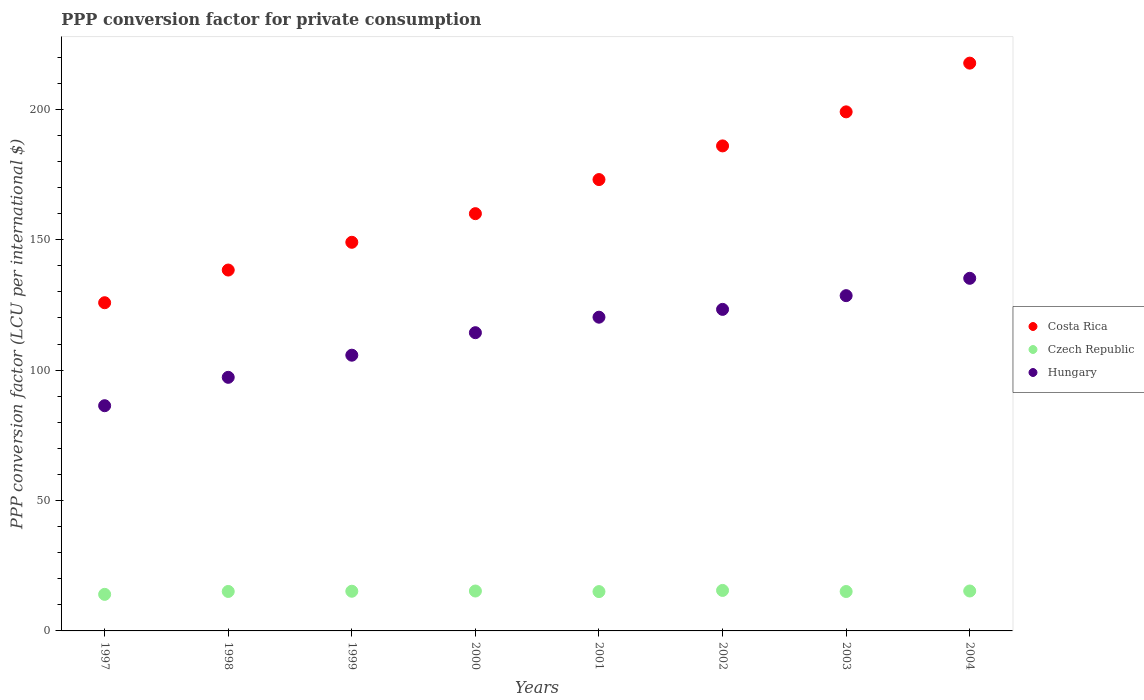How many different coloured dotlines are there?
Give a very brief answer. 3. Is the number of dotlines equal to the number of legend labels?
Make the answer very short. Yes. What is the PPP conversion factor for private consumption in Hungary in 2004?
Make the answer very short. 135.21. Across all years, what is the maximum PPP conversion factor for private consumption in Hungary?
Your answer should be compact. 135.21. Across all years, what is the minimum PPP conversion factor for private consumption in Costa Rica?
Your answer should be very brief. 125.85. In which year was the PPP conversion factor for private consumption in Hungary maximum?
Ensure brevity in your answer.  2004. In which year was the PPP conversion factor for private consumption in Hungary minimum?
Ensure brevity in your answer.  1997. What is the total PPP conversion factor for private consumption in Hungary in the graph?
Your answer should be compact. 911.07. What is the difference between the PPP conversion factor for private consumption in Czech Republic in 1999 and that in 2002?
Keep it short and to the point. -0.31. What is the difference between the PPP conversion factor for private consumption in Costa Rica in 2003 and the PPP conversion factor for private consumption in Czech Republic in 2001?
Your answer should be very brief. 183.96. What is the average PPP conversion factor for private consumption in Czech Republic per year?
Provide a short and direct response. 15.09. In the year 2003, what is the difference between the PPP conversion factor for private consumption in Czech Republic and PPP conversion factor for private consumption in Costa Rica?
Keep it short and to the point. -183.93. What is the ratio of the PPP conversion factor for private consumption in Hungary in 2000 to that in 2003?
Keep it short and to the point. 0.89. Is the difference between the PPP conversion factor for private consumption in Czech Republic in 1999 and 2003 greater than the difference between the PPP conversion factor for private consumption in Costa Rica in 1999 and 2003?
Keep it short and to the point. Yes. What is the difference between the highest and the second highest PPP conversion factor for private consumption in Hungary?
Your answer should be very brief. 6.65. What is the difference between the highest and the lowest PPP conversion factor for private consumption in Czech Republic?
Provide a short and direct response. 1.51. In how many years, is the PPP conversion factor for private consumption in Hungary greater than the average PPP conversion factor for private consumption in Hungary taken over all years?
Give a very brief answer. 5. Is the sum of the PPP conversion factor for private consumption in Costa Rica in 2000 and 2003 greater than the maximum PPP conversion factor for private consumption in Czech Republic across all years?
Your response must be concise. Yes. Is the PPP conversion factor for private consumption in Czech Republic strictly less than the PPP conversion factor for private consumption in Costa Rica over the years?
Make the answer very short. Yes. How many dotlines are there?
Offer a terse response. 3. Are the values on the major ticks of Y-axis written in scientific E-notation?
Give a very brief answer. No. Does the graph contain any zero values?
Your answer should be compact. No. How many legend labels are there?
Make the answer very short. 3. How are the legend labels stacked?
Provide a succinct answer. Vertical. What is the title of the graph?
Offer a terse response. PPP conversion factor for private consumption. Does "India" appear as one of the legend labels in the graph?
Ensure brevity in your answer.  No. What is the label or title of the X-axis?
Your answer should be compact. Years. What is the label or title of the Y-axis?
Make the answer very short. PPP conversion factor (LCU per international $). What is the PPP conversion factor (LCU per international $) of Costa Rica in 1997?
Offer a very short reply. 125.85. What is the PPP conversion factor (LCU per international $) in Czech Republic in 1997?
Give a very brief answer. 14.02. What is the PPP conversion factor (LCU per international $) in Hungary in 1997?
Make the answer very short. 86.36. What is the PPP conversion factor (LCU per international $) in Costa Rica in 1998?
Ensure brevity in your answer.  138.38. What is the PPP conversion factor (LCU per international $) in Czech Republic in 1998?
Give a very brief answer. 15.13. What is the PPP conversion factor (LCU per international $) of Hungary in 1998?
Offer a very short reply. 97.24. What is the PPP conversion factor (LCU per international $) in Costa Rica in 1999?
Keep it short and to the point. 149.02. What is the PPP conversion factor (LCU per international $) in Czech Republic in 1999?
Provide a succinct answer. 15.21. What is the PPP conversion factor (LCU per international $) of Hungary in 1999?
Offer a terse response. 105.73. What is the PPP conversion factor (LCU per international $) of Costa Rica in 2000?
Give a very brief answer. 160. What is the PPP conversion factor (LCU per international $) of Czech Republic in 2000?
Your answer should be very brief. 15.3. What is the PPP conversion factor (LCU per international $) in Hungary in 2000?
Give a very brief answer. 114.36. What is the PPP conversion factor (LCU per international $) in Costa Rica in 2001?
Your answer should be compact. 173.07. What is the PPP conversion factor (LCU per international $) of Czech Republic in 2001?
Provide a short and direct response. 15.08. What is the PPP conversion factor (LCU per international $) of Hungary in 2001?
Provide a succinct answer. 120.3. What is the PPP conversion factor (LCU per international $) in Costa Rica in 2002?
Make the answer very short. 185.99. What is the PPP conversion factor (LCU per international $) of Czech Republic in 2002?
Provide a succinct answer. 15.53. What is the PPP conversion factor (LCU per international $) of Hungary in 2002?
Provide a short and direct response. 123.3. What is the PPP conversion factor (LCU per international $) of Costa Rica in 2003?
Your answer should be very brief. 199.04. What is the PPP conversion factor (LCU per international $) in Czech Republic in 2003?
Offer a very short reply. 15.11. What is the PPP conversion factor (LCU per international $) of Hungary in 2003?
Offer a very short reply. 128.56. What is the PPP conversion factor (LCU per international $) in Costa Rica in 2004?
Give a very brief answer. 217.72. What is the PPP conversion factor (LCU per international $) of Czech Republic in 2004?
Provide a succinct answer. 15.31. What is the PPP conversion factor (LCU per international $) in Hungary in 2004?
Ensure brevity in your answer.  135.21. Across all years, what is the maximum PPP conversion factor (LCU per international $) in Costa Rica?
Give a very brief answer. 217.72. Across all years, what is the maximum PPP conversion factor (LCU per international $) of Czech Republic?
Offer a terse response. 15.53. Across all years, what is the maximum PPP conversion factor (LCU per international $) of Hungary?
Make the answer very short. 135.21. Across all years, what is the minimum PPP conversion factor (LCU per international $) of Costa Rica?
Give a very brief answer. 125.85. Across all years, what is the minimum PPP conversion factor (LCU per international $) in Czech Republic?
Your response must be concise. 14.02. Across all years, what is the minimum PPP conversion factor (LCU per international $) in Hungary?
Provide a short and direct response. 86.36. What is the total PPP conversion factor (LCU per international $) of Costa Rica in the graph?
Your answer should be very brief. 1349.08. What is the total PPP conversion factor (LCU per international $) in Czech Republic in the graph?
Provide a short and direct response. 120.7. What is the total PPP conversion factor (LCU per international $) of Hungary in the graph?
Your answer should be very brief. 911.07. What is the difference between the PPP conversion factor (LCU per international $) of Costa Rica in 1997 and that in 1998?
Ensure brevity in your answer.  -12.53. What is the difference between the PPP conversion factor (LCU per international $) in Czech Republic in 1997 and that in 1998?
Make the answer very short. -1.11. What is the difference between the PPP conversion factor (LCU per international $) in Hungary in 1997 and that in 1998?
Provide a short and direct response. -10.88. What is the difference between the PPP conversion factor (LCU per international $) of Costa Rica in 1997 and that in 1999?
Give a very brief answer. -23.17. What is the difference between the PPP conversion factor (LCU per international $) in Czech Republic in 1997 and that in 1999?
Give a very brief answer. -1.2. What is the difference between the PPP conversion factor (LCU per international $) of Hungary in 1997 and that in 1999?
Offer a very short reply. -19.37. What is the difference between the PPP conversion factor (LCU per international $) in Costa Rica in 1997 and that in 2000?
Ensure brevity in your answer.  -34.15. What is the difference between the PPP conversion factor (LCU per international $) of Czech Republic in 1997 and that in 2000?
Provide a short and direct response. -1.28. What is the difference between the PPP conversion factor (LCU per international $) of Hungary in 1997 and that in 2000?
Your answer should be very brief. -28. What is the difference between the PPP conversion factor (LCU per international $) in Costa Rica in 1997 and that in 2001?
Ensure brevity in your answer.  -47.23. What is the difference between the PPP conversion factor (LCU per international $) in Czech Republic in 1997 and that in 2001?
Provide a short and direct response. -1.06. What is the difference between the PPP conversion factor (LCU per international $) in Hungary in 1997 and that in 2001?
Your response must be concise. -33.94. What is the difference between the PPP conversion factor (LCU per international $) in Costa Rica in 1997 and that in 2002?
Your answer should be compact. -60.14. What is the difference between the PPP conversion factor (LCU per international $) in Czech Republic in 1997 and that in 2002?
Offer a very short reply. -1.51. What is the difference between the PPP conversion factor (LCU per international $) of Hungary in 1997 and that in 2002?
Offer a very short reply. -36.94. What is the difference between the PPP conversion factor (LCU per international $) in Costa Rica in 1997 and that in 2003?
Make the answer very short. -73.19. What is the difference between the PPP conversion factor (LCU per international $) of Czech Republic in 1997 and that in 2003?
Ensure brevity in your answer.  -1.09. What is the difference between the PPP conversion factor (LCU per international $) in Hungary in 1997 and that in 2003?
Offer a terse response. -42.2. What is the difference between the PPP conversion factor (LCU per international $) in Costa Rica in 1997 and that in 2004?
Offer a very short reply. -91.87. What is the difference between the PPP conversion factor (LCU per international $) in Czech Republic in 1997 and that in 2004?
Your answer should be very brief. -1.29. What is the difference between the PPP conversion factor (LCU per international $) of Hungary in 1997 and that in 2004?
Keep it short and to the point. -48.85. What is the difference between the PPP conversion factor (LCU per international $) in Costa Rica in 1998 and that in 1999?
Your answer should be compact. -10.64. What is the difference between the PPP conversion factor (LCU per international $) of Czech Republic in 1998 and that in 1999?
Make the answer very short. -0.08. What is the difference between the PPP conversion factor (LCU per international $) of Hungary in 1998 and that in 1999?
Provide a succinct answer. -8.49. What is the difference between the PPP conversion factor (LCU per international $) of Costa Rica in 1998 and that in 2000?
Your response must be concise. -21.62. What is the difference between the PPP conversion factor (LCU per international $) in Czech Republic in 1998 and that in 2000?
Offer a terse response. -0.17. What is the difference between the PPP conversion factor (LCU per international $) in Hungary in 1998 and that in 2000?
Provide a succinct answer. -17.11. What is the difference between the PPP conversion factor (LCU per international $) in Costa Rica in 1998 and that in 2001?
Your answer should be very brief. -34.69. What is the difference between the PPP conversion factor (LCU per international $) of Czech Republic in 1998 and that in 2001?
Keep it short and to the point. 0.05. What is the difference between the PPP conversion factor (LCU per international $) in Hungary in 1998 and that in 2001?
Your response must be concise. -23.06. What is the difference between the PPP conversion factor (LCU per international $) in Costa Rica in 1998 and that in 2002?
Provide a short and direct response. -47.6. What is the difference between the PPP conversion factor (LCU per international $) in Czech Republic in 1998 and that in 2002?
Keep it short and to the point. -0.39. What is the difference between the PPP conversion factor (LCU per international $) of Hungary in 1998 and that in 2002?
Provide a succinct answer. -26.06. What is the difference between the PPP conversion factor (LCU per international $) in Costa Rica in 1998 and that in 2003?
Offer a very short reply. -60.66. What is the difference between the PPP conversion factor (LCU per international $) in Czech Republic in 1998 and that in 2003?
Provide a short and direct response. 0.02. What is the difference between the PPP conversion factor (LCU per international $) in Hungary in 1998 and that in 2003?
Your response must be concise. -31.32. What is the difference between the PPP conversion factor (LCU per international $) of Costa Rica in 1998 and that in 2004?
Your answer should be compact. -79.34. What is the difference between the PPP conversion factor (LCU per international $) of Czech Republic in 1998 and that in 2004?
Make the answer very short. -0.18. What is the difference between the PPP conversion factor (LCU per international $) of Hungary in 1998 and that in 2004?
Offer a terse response. -37.97. What is the difference between the PPP conversion factor (LCU per international $) of Costa Rica in 1999 and that in 2000?
Offer a terse response. -10.98. What is the difference between the PPP conversion factor (LCU per international $) of Czech Republic in 1999 and that in 2000?
Your answer should be very brief. -0.09. What is the difference between the PPP conversion factor (LCU per international $) in Hungary in 1999 and that in 2000?
Your answer should be very brief. -8.63. What is the difference between the PPP conversion factor (LCU per international $) in Costa Rica in 1999 and that in 2001?
Give a very brief answer. -24.05. What is the difference between the PPP conversion factor (LCU per international $) in Czech Republic in 1999 and that in 2001?
Your answer should be very brief. 0.13. What is the difference between the PPP conversion factor (LCU per international $) of Hungary in 1999 and that in 2001?
Give a very brief answer. -14.57. What is the difference between the PPP conversion factor (LCU per international $) in Costa Rica in 1999 and that in 2002?
Provide a succinct answer. -36.96. What is the difference between the PPP conversion factor (LCU per international $) of Czech Republic in 1999 and that in 2002?
Keep it short and to the point. -0.31. What is the difference between the PPP conversion factor (LCU per international $) in Hungary in 1999 and that in 2002?
Make the answer very short. -17.57. What is the difference between the PPP conversion factor (LCU per international $) of Costa Rica in 1999 and that in 2003?
Offer a very short reply. -50.02. What is the difference between the PPP conversion factor (LCU per international $) in Czech Republic in 1999 and that in 2003?
Offer a very short reply. 0.1. What is the difference between the PPP conversion factor (LCU per international $) in Hungary in 1999 and that in 2003?
Ensure brevity in your answer.  -22.83. What is the difference between the PPP conversion factor (LCU per international $) in Costa Rica in 1999 and that in 2004?
Offer a terse response. -68.7. What is the difference between the PPP conversion factor (LCU per international $) of Czech Republic in 1999 and that in 2004?
Offer a very short reply. -0.1. What is the difference between the PPP conversion factor (LCU per international $) in Hungary in 1999 and that in 2004?
Your answer should be compact. -29.48. What is the difference between the PPP conversion factor (LCU per international $) of Costa Rica in 2000 and that in 2001?
Your answer should be compact. -13.07. What is the difference between the PPP conversion factor (LCU per international $) of Czech Republic in 2000 and that in 2001?
Your answer should be compact. 0.22. What is the difference between the PPP conversion factor (LCU per international $) in Hungary in 2000 and that in 2001?
Provide a succinct answer. -5.95. What is the difference between the PPP conversion factor (LCU per international $) of Costa Rica in 2000 and that in 2002?
Provide a short and direct response. -25.98. What is the difference between the PPP conversion factor (LCU per international $) of Czech Republic in 2000 and that in 2002?
Your answer should be very brief. -0.23. What is the difference between the PPP conversion factor (LCU per international $) of Hungary in 2000 and that in 2002?
Your answer should be compact. -8.94. What is the difference between the PPP conversion factor (LCU per international $) of Costa Rica in 2000 and that in 2003?
Provide a succinct answer. -39.04. What is the difference between the PPP conversion factor (LCU per international $) of Czech Republic in 2000 and that in 2003?
Your answer should be compact. 0.19. What is the difference between the PPP conversion factor (LCU per international $) of Hungary in 2000 and that in 2003?
Your response must be concise. -14.2. What is the difference between the PPP conversion factor (LCU per international $) of Costa Rica in 2000 and that in 2004?
Your response must be concise. -57.72. What is the difference between the PPP conversion factor (LCU per international $) in Czech Republic in 2000 and that in 2004?
Make the answer very short. -0.01. What is the difference between the PPP conversion factor (LCU per international $) in Hungary in 2000 and that in 2004?
Your response must be concise. -20.85. What is the difference between the PPP conversion factor (LCU per international $) of Costa Rica in 2001 and that in 2002?
Ensure brevity in your answer.  -12.91. What is the difference between the PPP conversion factor (LCU per international $) in Czech Republic in 2001 and that in 2002?
Your answer should be very brief. -0.45. What is the difference between the PPP conversion factor (LCU per international $) in Hungary in 2001 and that in 2002?
Provide a short and direct response. -3. What is the difference between the PPP conversion factor (LCU per international $) of Costa Rica in 2001 and that in 2003?
Give a very brief answer. -25.96. What is the difference between the PPP conversion factor (LCU per international $) of Czech Republic in 2001 and that in 2003?
Provide a succinct answer. -0.03. What is the difference between the PPP conversion factor (LCU per international $) in Hungary in 2001 and that in 2003?
Your response must be concise. -8.26. What is the difference between the PPP conversion factor (LCU per international $) of Costa Rica in 2001 and that in 2004?
Your response must be concise. -44.65. What is the difference between the PPP conversion factor (LCU per international $) in Czech Republic in 2001 and that in 2004?
Your answer should be compact. -0.23. What is the difference between the PPP conversion factor (LCU per international $) of Hungary in 2001 and that in 2004?
Give a very brief answer. -14.91. What is the difference between the PPP conversion factor (LCU per international $) in Costa Rica in 2002 and that in 2003?
Give a very brief answer. -13.05. What is the difference between the PPP conversion factor (LCU per international $) in Czech Republic in 2002 and that in 2003?
Make the answer very short. 0.42. What is the difference between the PPP conversion factor (LCU per international $) of Hungary in 2002 and that in 2003?
Offer a very short reply. -5.26. What is the difference between the PPP conversion factor (LCU per international $) in Costa Rica in 2002 and that in 2004?
Give a very brief answer. -31.74. What is the difference between the PPP conversion factor (LCU per international $) of Czech Republic in 2002 and that in 2004?
Provide a short and direct response. 0.22. What is the difference between the PPP conversion factor (LCU per international $) of Hungary in 2002 and that in 2004?
Your answer should be very brief. -11.91. What is the difference between the PPP conversion factor (LCU per international $) in Costa Rica in 2003 and that in 2004?
Your response must be concise. -18.68. What is the difference between the PPP conversion factor (LCU per international $) of Czech Republic in 2003 and that in 2004?
Offer a terse response. -0.2. What is the difference between the PPP conversion factor (LCU per international $) of Hungary in 2003 and that in 2004?
Keep it short and to the point. -6.65. What is the difference between the PPP conversion factor (LCU per international $) of Costa Rica in 1997 and the PPP conversion factor (LCU per international $) of Czech Republic in 1998?
Provide a succinct answer. 110.72. What is the difference between the PPP conversion factor (LCU per international $) of Costa Rica in 1997 and the PPP conversion factor (LCU per international $) of Hungary in 1998?
Your answer should be compact. 28.61. What is the difference between the PPP conversion factor (LCU per international $) of Czech Republic in 1997 and the PPP conversion factor (LCU per international $) of Hungary in 1998?
Your answer should be compact. -83.22. What is the difference between the PPP conversion factor (LCU per international $) of Costa Rica in 1997 and the PPP conversion factor (LCU per international $) of Czech Republic in 1999?
Make the answer very short. 110.63. What is the difference between the PPP conversion factor (LCU per international $) in Costa Rica in 1997 and the PPP conversion factor (LCU per international $) in Hungary in 1999?
Your answer should be compact. 20.12. What is the difference between the PPP conversion factor (LCU per international $) of Czech Republic in 1997 and the PPP conversion factor (LCU per international $) of Hungary in 1999?
Provide a succinct answer. -91.71. What is the difference between the PPP conversion factor (LCU per international $) in Costa Rica in 1997 and the PPP conversion factor (LCU per international $) in Czech Republic in 2000?
Offer a very short reply. 110.55. What is the difference between the PPP conversion factor (LCU per international $) in Costa Rica in 1997 and the PPP conversion factor (LCU per international $) in Hungary in 2000?
Offer a terse response. 11.49. What is the difference between the PPP conversion factor (LCU per international $) of Czech Republic in 1997 and the PPP conversion factor (LCU per international $) of Hungary in 2000?
Keep it short and to the point. -100.34. What is the difference between the PPP conversion factor (LCU per international $) in Costa Rica in 1997 and the PPP conversion factor (LCU per international $) in Czech Republic in 2001?
Offer a very short reply. 110.77. What is the difference between the PPP conversion factor (LCU per international $) of Costa Rica in 1997 and the PPP conversion factor (LCU per international $) of Hungary in 2001?
Give a very brief answer. 5.55. What is the difference between the PPP conversion factor (LCU per international $) of Czech Republic in 1997 and the PPP conversion factor (LCU per international $) of Hungary in 2001?
Make the answer very short. -106.28. What is the difference between the PPP conversion factor (LCU per international $) of Costa Rica in 1997 and the PPP conversion factor (LCU per international $) of Czech Republic in 2002?
Ensure brevity in your answer.  110.32. What is the difference between the PPP conversion factor (LCU per international $) of Costa Rica in 1997 and the PPP conversion factor (LCU per international $) of Hungary in 2002?
Keep it short and to the point. 2.55. What is the difference between the PPP conversion factor (LCU per international $) in Czech Republic in 1997 and the PPP conversion factor (LCU per international $) in Hungary in 2002?
Your response must be concise. -109.28. What is the difference between the PPP conversion factor (LCU per international $) of Costa Rica in 1997 and the PPP conversion factor (LCU per international $) of Czech Republic in 2003?
Ensure brevity in your answer.  110.74. What is the difference between the PPP conversion factor (LCU per international $) in Costa Rica in 1997 and the PPP conversion factor (LCU per international $) in Hungary in 2003?
Offer a very short reply. -2.71. What is the difference between the PPP conversion factor (LCU per international $) in Czech Republic in 1997 and the PPP conversion factor (LCU per international $) in Hungary in 2003?
Provide a short and direct response. -114.54. What is the difference between the PPP conversion factor (LCU per international $) in Costa Rica in 1997 and the PPP conversion factor (LCU per international $) in Czech Republic in 2004?
Give a very brief answer. 110.54. What is the difference between the PPP conversion factor (LCU per international $) of Costa Rica in 1997 and the PPP conversion factor (LCU per international $) of Hungary in 2004?
Make the answer very short. -9.36. What is the difference between the PPP conversion factor (LCU per international $) of Czech Republic in 1997 and the PPP conversion factor (LCU per international $) of Hungary in 2004?
Your answer should be compact. -121.19. What is the difference between the PPP conversion factor (LCU per international $) of Costa Rica in 1998 and the PPP conversion factor (LCU per international $) of Czech Republic in 1999?
Give a very brief answer. 123.17. What is the difference between the PPP conversion factor (LCU per international $) in Costa Rica in 1998 and the PPP conversion factor (LCU per international $) in Hungary in 1999?
Give a very brief answer. 32.65. What is the difference between the PPP conversion factor (LCU per international $) of Czech Republic in 1998 and the PPP conversion factor (LCU per international $) of Hungary in 1999?
Your response must be concise. -90.6. What is the difference between the PPP conversion factor (LCU per international $) of Costa Rica in 1998 and the PPP conversion factor (LCU per international $) of Czech Republic in 2000?
Provide a short and direct response. 123.08. What is the difference between the PPP conversion factor (LCU per international $) of Costa Rica in 1998 and the PPP conversion factor (LCU per international $) of Hungary in 2000?
Offer a very short reply. 24.02. What is the difference between the PPP conversion factor (LCU per international $) in Czech Republic in 1998 and the PPP conversion factor (LCU per international $) in Hungary in 2000?
Give a very brief answer. -99.22. What is the difference between the PPP conversion factor (LCU per international $) of Costa Rica in 1998 and the PPP conversion factor (LCU per international $) of Czech Republic in 2001?
Your response must be concise. 123.3. What is the difference between the PPP conversion factor (LCU per international $) of Costa Rica in 1998 and the PPP conversion factor (LCU per international $) of Hungary in 2001?
Give a very brief answer. 18.08. What is the difference between the PPP conversion factor (LCU per international $) of Czech Republic in 1998 and the PPP conversion factor (LCU per international $) of Hungary in 2001?
Offer a terse response. -105.17. What is the difference between the PPP conversion factor (LCU per international $) of Costa Rica in 1998 and the PPP conversion factor (LCU per international $) of Czech Republic in 2002?
Ensure brevity in your answer.  122.86. What is the difference between the PPP conversion factor (LCU per international $) in Costa Rica in 1998 and the PPP conversion factor (LCU per international $) in Hungary in 2002?
Your response must be concise. 15.08. What is the difference between the PPP conversion factor (LCU per international $) in Czech Republic in 1998 and the PPP conversion factor (LCU per international $) in Hungary in 2002?
Ensure brevity in your answer.  -108.17. What is the difference between the PPP conversion factor (LCU per international $) in Costa Rica in 1998 and the PPP conversion factor (LCU per international $) in Czech Republic in 2003?
Keep it short and to the point. 123.27. What is the difference between the PPP conversion factor (LCU per international $) of Costa Rica in 1998 and the PPP conversion factor (LCU per international $) of Hungary in 2003?
Offer a very short reply. 9.82. What is the difference between the PPP conversion factor (LCU per international $) in Czech Republic in 1998 and the PPP conversion factor (LCU per international $) in Hungary in 2003?
Ensure brevity in your answer.  -113.43. What is the difference between the PPP conversion factor (LCU per international $) of Costa Rica in 1998 and the PPP conversion factor (LCU per international $) of Czech Republic in 2004?
Your answer should be compact. 123.07. What is the difference between the PPP conversion factor (LCU per international $) of Costa Rica in 1998 and the PPP conversion factor (LCU per international $) of Hungary in 2004?
Your answer should be compact. 3.17. What is the difference between the PPP conversion factor (LCU per international $) of Czech Republic in 1998 and the PPP conversion factor (LCU per international $) of Hungary in 2004?
Provide a succinct answer. -120.08. What is the difference between the PPP conversion factor (LCU per international $) in Costa Rica in 1999 and the PPP conversion factor (LCU per international $) in Czech Republic in 2000?
Offer a very short reply. 133.72. What is the difference between the PPP conversion factor (LCU per international $) in Costa Rica in 1999 and the PPP conversion factor (LCU per international $) in Hungary in 2000?
Give a very brief answer. 34.67. What is the difference between the PPP conversion factor (LCU per international $) of Czech Republic in 1999 and the PPP conversion factor (LCU per international $) of Hungary in 2000?
Offer a terse response. -99.14. What is the difference between the PPP conversion factor (LCU per international $) of Costa Rica in 1999 and the PPP conversion factor (LCU per international $) of Czech Republic in 2001?
Ensure brevity in your answer.  133.94. What is the difference between the PPP conversion factor (LCU per international $) in Costa Rica in 1999 and the PPP conversion factor (LCU per international $) in Hungary in 2001?
Make the answer very short. 28.72. What is the difference between the PPP conversion factor (LCU per international $) in Czech Republic in 1999 and the PPP conversion factor (LCU per international $) in Hungary in 2001?
Offer a very short reply. -105.09. What is the difference between the PPP conversion factor (LCU per international $) in Costa Rica in 1999 and the PPP conversion factor (LCU per international $) in Czech Republic in 2002?
Your answer should be very brief. 133.5. What is the difference between the PPP conversion factor (LCU per international $) in Costa Rica in 1999 and the PPP conversion factor (LCU per international $) in Hungary in 2002?
Offer a very short reply. 25.73. What is the difference between the PPP conversion factor (LCU per international $) of Czech Republic in 1999 and the PPP conversion factor (LCU per international $) of Hungary in 2002?
Make the answer very short. -108.08. What is the difference between the PPP conversion factor (LCU per international $) in Costa Rica in 1999 and the PPP conversion factor (LCU per international $) in Czech Republic in 2003?
Offer a very short reply. 133.91. What is the difference between the PPP conversion factor (LCU per international $) in Costa Rica in 1999 and the PPP conversion factor (LCU per international $) in Hungary in 2003?
Provide a short and direct response. 20.46. What is the difference between the PPP conversion factor (LCU per international $) of Czech Republic in 1999 and the PPP conversion factor (LCU per international $) of Hungary in 2003?
Your answer should be very brief. -113.35. What is the difference between the PPP conversion factor (LCU per international $) in Costa Rica in 1999 and the PPP conversion factor (LCU per international $) in Czech Republic in 2004?
Give a very brief answer. 133.71. What is the difference between the PPP conversion factor (LCU per international $) in Costa Rica in 1999 and the PPP conversion factor (LCU per international $) in Hungary in 2004?
Keep it short and to the point. 13.81. What is the difference between the PPP conversion factor (LCU per international $) of Czech Republic in 1999 and the PPP conversion factor (LCU per international $) of Hungary in 2004?
Provide a succinct answer. -120. What is the difference between the PPP conversion factor (LCU per international $) of Costa Rica in 2000 and the PPP conversion factor (LCU per international $) of Czech Republic in 2001?
Your response must be concise. 144.92. What is the difference between the PPP conversion factor (LCU per international $) of Costa Rica in 2000 and the PPP conversion factor (LCU per international $) of Hungary in 2001?
Ensure brevity in your answer.  39.7. What is the difference between the PPP conversion factor (LCU per international $) of Czech Republic in 2000 and the PPP conversion factor (LCU per international $) of Hungary in 2001?
Keep it short and to the point. -105. What is the difference between the PPP conversion factor (LCU per international $) in Costa Rica in 2000 and the PPP conversion factor (LCU per international $) in Czech Republic in 2002?
Offer a terse response. 144.47. What is the difference between the PPP conversion factor (LCU per international $) in Costa Rica in 2000 and the PPP conversion factor (LCU per international $) in Hungary in 2002?
Your response must be concise. 36.7. What is the difference between the PPP conversion factor (LCU per international $) of Czech Republic in 2000 and the PPP conversion factor (LCU per international $) of Hungary in 2002?
Your response must be concise. -108. What is the difference between the PPP conversion factor (LCU per international $) in Costa Rica in 2000 and the PPP conversion factor (LCU per international $) in Czech Republic in 2003?
Keep it short and to the point. 144.89. What is the difference between the PPP conversion factor (LCU per international $) of Costa Rica in 2000 and the PPP conversion factor (LCU per international $) of Hungary in 2003?
Provide a short and direct response. 31.44. What is the difference between the PPP conversion factor (LCU per international $) in Czech Republic in 2000 and the PPP conversion factor (LCU per international $) in Hungary in 2003?
Provide a succinct answer. -113.26. What is the difference between the PPP conversion factor (LCU per international $) of Costa Rica in 2000 and the PPP conversion factor (LCU per international $) of Czech Republic in 2004?
Your answer should be very brief. 144.69. What is the difference between the PPP conversion factor (LCU per international $) in Costa Rica in 2000 and the PPP conversion factor (LCU per international $) in Hungary in 2004?
Offer a terse response. 24.79. What is the difference between the PPP conversion factor (LCU per international $) in Czech Republic in 2000 and the PPP conversion factor (LCU per international $) in Hungary in 2004?
Make the answer very short. -119.91. What is the difference between the PPP conversion factor (LCU per international $) in Costa Rica in 2001 and the PPP conversion factor (LCU per international $) in Czech Republic in 2002?
Keep it short and to the point. 157.55. What is the difference between the PPP conversion factor (LCU per international $) in Costa Rica in 2001 and the PPP conversion factor (LCU per international $) in Hungary in 2002?
Offer a very short reply. 49.78. What is the difference between the PPP conversion factor (LCU per international $) of Czech Republic in 2001 and the PPP conversion factor (LCU per international $) of Hungary in 2002?
Ensure brevity in your answer.  -108.22. What is the difference between the PPP conversion factor (LCU per international $) of Costa Rica in 2001 and the PPP conversion factor (LCU per international $) of Czech Republic in 2003?
Provide a short and direct response. 157.96. What is the difference between the PPP conversion factor (LCU per international $) of Costa Rica in 2001 and the PPP conversion factor (LCU per international $) of Hungary in 2003?
Your answer should be compact. 44.51. What is the difference between the PPP conversion factor (LCU per international $) of Czech Republic in 2001 and the PPP conversion factor (LCU per international $) of Hungary in 2003?
Your response must be concise. -113.48. What is the difference between the PPP conversion factor (LCU per international $) of Costa Rica in 2001 and the PPP conversion factor (LCU per international $) of Czech Republic in 2004?
Offer a terse response. 157.76. What is the difference between the PPP conversion factor (LCU per international $) of Costa Rica in 2001 and the PPP conversion factor (LCU per international $) of Hungary in 2004?
Provide a succinct answer. 37.86. What is the difference between the PPP conversion factor (LCU per international $) of Czech Republic in 2001 and the PPP conversion factor (LCU per international $) of Hungary in 2004?
Ensure brevity in your answer.  -120.13. What is the difference between the PPP conversion factor (LCU per international $) in Costa Rica in 2002 and the PPP conversion factor (LCU per international $) in Czech Republic in 2003?
Your answer should be compact. 170.87. What is the difference between the PPP conversion factor (LCU per international $) in Costa Rica in 2002 and the PPP conversion factor (LCU per international $) in Hungary in 2003?
Offer a very short reply. 57.43. What is the difference between the PPP conversion factor (LCU per international $) in Czech Republic in 2002 and the PPP conversion factor (LCU per international $) in Hungary in 2003?
Make the answer very short. -113.03. What is the difference between the PPP conversion factor (LCU per international $) of Costa Rica in 2002 and the PPP conversion factor (LCU per international $) of Czech Republic in 2004?
Your response must be concise. 170.68. What is the difference between the PPP conversion factor (LCU per international $) of Costa Rica in 2002 and the PPP conversion factor (LCU per international $) of Hungary in 2004?
Give a very brief answer. 50.77. What is the difference between the PPP conversion factor (LCU per international $) of Czech Republic in 2002 and the PPP conversion factor (LCU per international $) of Hungary in 2004?
Offer a terse response. -119.68. What is the difference between the PPP conversion factor (LCU per international $) of Costa Rica in 2003 and the PPP conversion factor (LCU per international $) of Czech Republic in 2004?
Offer a terse response. 183.73. What is the difference between the PPP conversion factor (LCU per international $) of Costa Rica in 2003 and the PPP conversion factor (LCU per international $) of Hungary in 2004?
Provide a short and direct response. 63.83. What is the difference between the PPP conversion factor (LCU per international $) of Czech Republic in 2003 and the PPP conversion factor (LCU per international $) of Hungary in 2004?
Your response must be concise. -120.1. What is the average PPP conversion factor (LCU per international $) in Costa Rica per year?
Make the answer very short. 168.63. What is the average PPP conversion factor (LCU per international $) of Czech Republic per year?
Give a very brief answer. 15.09. What is the average PPP conversion factor (LCU per international $) of Hungary per year?
Give a very brief answer. 113.88. In the year 1997, what is the difference between the PPP conversion factor (LCU per international $) in Costa Rica and PPP conversion factor (LCU per international $) in Czech Republic?
Offer a terse response. 111.83. In the year 1997, what is the difference between the PPP conversion factor (LCU per international $) of Costa Rica and PPP conversion factor (LCU per international $) of Hungary?
Give a very brief answer. 39.49. In the year 1997, what is the difference between the PPP conversion factor (LCU per international $) of Czech Republic and PPP conversion factor (LCU per international $) of Hungary?
Your response must be concise. -72.34. In the year 1998, what is the difference between the PPP conversion factor (LCU per international $) of Costa Rica and PPP conversion factor (LCU per international $) of Czech Republic?
Give a very brief answer. 123.25. In the year 1998, what is the difference between the PPP conversion factor (LCU per international $) in Costa Rica and PPP conversion factor (LCU per international $) in Hungary?
Provide a short and direct response. 41.14. In the year 1998, what is the difference between the PPP conversion factor (LCU per international $) in Czech Republic and PPP conversion factor (LCU per international $) in Hungary?
Your answer should be very brief. -82.11. In the year 1999, what is the difference between the PPP conversion factor (LCU per international $) in Costa Rica and PPP conversion factor (LCU per international $) in Czech Republic?
Your answer should be compact. 133.81. In the year 1999, what is the difference between the PPP conversion factor (LCU per international $) in Costa Rica and PPP conversion factor (LCU per international $) in Hungary?
Provide a short and direct response. 43.29. In the year 1999, what is the difference between the PPP conversion factor (LCU per international $) of Czech Republic and PPP conversion factor (LCU per international $) of Hungary?
Offer a terse response. -90.52. In the year 2000, what is the difference between the PPP conversion factor (LCU per international $) in Costa Rica and PPP conversion factor (LCU per international $) in Czech Republic?
Your answer should be compact. 144.7. In the year 2000, what is the difference between the PPP conversion factor (LCU per international $) of Costa Rica and PPP conversion factor (LCU per international $) of Hungary?
Give a very brief answer. 45.64. In the year 2000, what is the difference between the PPP conversion factor (LCU per international $) in Czech Republic and PPP conversion factor (LCU per international $) in Hungary?
Make the answer very short. -99.06. In the year 2001, what is the difference between the PPP conversion factor (LCU per international $) of Costa Rica and PPP conversion factor (LCU per international $) of Czech Republic?
Keep it short and to the point. 157.99. In the year 2001, what is the difference between the PPP conversion factor (LCU per international $) in Costa Rica and PPP conversion factor (LCU per international $) in Hungary?
Make the answer very short. 52.77. In the year 2001, what is the difference between the PPP conversion factor (LCU per international $) of Czech Republic and PPP conversion factor (LCU per international $) of Hungary?
Provide a succinct answer. -105.22. In the year 2002, what is the difference between the PPP conversion factor (LCU per international $) of Costa Rica and PPP conversion factor (LCU per international $) of Czech Republic?
Your answer should be very brief. 170.46. In the year 2002, what is the difference between the PPP conversion factor (LCU per international $) in Costa Rica and PPP conversion factor (LCU per international $) in Hungary?
Offer a terse response. 62.69. In the year 2002, what is the difference between the PPP conversion factor (LCU per international $) of Czech Republic and PPP conversion factor (LCU per international $) of Hungary?
Offer a terse response. -107.77. In the year 2003, what is the difference between the PPP conversion factor (LCU per international $) in Costa Rica and PPP conversion factor (LCU per international $) in Czech Republic?
Make the answer very short. 183.93. In the year 2003, what is the difference between the PPP conversion factor (LCU per international $) of Costa Rica and PPP conversion factor (LCU per international $) of Hungary?
Your answer should be compact. 70.48. In the year 2003, what is the difference between the PPP conversion factor (LCU per international $) of Czech Republic and PPP conversion factor (LCU per international $) of Hungary?
Provide a short and direct response. -113.45. In the year 2004, what is the difference between the PPP conversion factor (LCU per international $) in Costa Rica and PPP conversion factor (LCU per international $) in Czech Republic?
Keep it short and to the point. 202.41. In the year 2004, what is the difference between the PPP conversion factor (LCU per international $) of Costa Rica and PPP conversion factor (LCU per international $) of Hungary?
Make the answer very short. 82.51. In the year 2004, what is the difference between the PPP conversion factor (LCU per international $) of Czech Republic and PPP conversion factor (LCU per international $) of Hungary?
Offer a terse response. -119.9. What is the ratio of the PPP conversion factor (LCU per international $) of Costa Rica in 1997 to that in 1998?
Offer a terse response. 0.91. What is the ratio of the PPP conversion factor (LCU per international $) in Czech Republic in 1997 to that in 1998?
Offer a terse response. 0.93. What is the ratio of the PPP conversion factor (LCU per international $) in Hungary in 1997 to that in 1998?
Provide a short and direct response. 0.89. What is the ratio of the PPP conversion factor (LCU per international $) in Costa Rica in 1997 to that in 1999?
Give a very brief answer. 0.84. What is the ratio of the PPP conversion factor (LCU per international $) of Czech Republic in 1997 to that in 1999?
Keep it short and to the point. 0.92. What is the ratio of the PPP conversion factor (LCU per international $) in Hungary in 1997 to that in 1999?
Ensure brevity in your answer.  0.82. What is the ratio of the PPP conversion factor (LCU per international $) of Costa Rica in 1997 to that in 2000?
Ensure brevity in your answer.  0.79. What is the ratio of the PPP conversion factor (LCU per international $) in Czech Republic in 1997 to that in 2000?
Your answer should be very brief. 0.92. What is the ratio of the PPP conversion factor (LCU per international $) in Hungary in 1997 to that in 2000?
Your answer should be very brief. 0.76. What is the ratio of the PPP conversion factor (LCU per international $) in Costa Rica in 1997 to that in 2001?
Provide a short and direct response. 0.73. What is the ratio of the PPP conversion factor (LCU per international $) of Czech Republic in 1997 to that in 2001?
Offer a very short reply. 0.93. What is the ratio of the PPP conversion factor (LCU per international $) of Hungary in 1997 to that in 2001?
Provide a short and direct response. 0.72. What is the ratio of the PPP conversion factor (LCU per international $) in Costa Rica in 1997 to that in 2002?
Offer a terse response. 0.68. What is the ratio of the PPP conversion factor (LCU per international $) in Czech Republic in 1997 to that in 2002?
Your answer should be very brief. 0.9. What is the ratio of the PPP conversion factor (LCU per international $) of Hungary in 1997 to that in 2002?
Provide a succinct answer. 0.7. What is the ratio of the PPP conversion factor (LCU per international $) of Costa Rica in 1997 to that in 2003?
Make the answer very short. 0.63. What is the ratio of the PPP conversion factor (LCU per international $) of Czech Republic in 1997 to that in 2003?
Offer a terse response. 0.93. What is the ratio of the PPP conversion factor (LCU per international $) in Hungary in 1997 to that in 2003?
Provide a short and direct response. 0.67. What is the ratio of the PPP conversion factor (LCU per international $) in Costa Rica in 1997 to that in 2004?
Provide a short and direct response. 0.58. What is the ratio of the PPP conversion factor (LCU per international $) in Czech Republic in 1997 to that in 2004?
Your response must be concise. 0.92. What is the ratio of the PPP conversion factor (LCU per international $) of Hungary in 1997 to that in 2004?
Offer a very short reply. 0.64. What is the ratio of the PPP conversion factor (LCU per international $) of Hungary in 1998 to that in 1999?
Provide a short and direct response. 0.92. What is the ratio of the PPP conversion factor (LCU per international $) of Costa Rica in 1998 to that in 2000?
Offer a very short reply. 0.86. What is the ratio of the PPP conversion factor (LCU per international $) in Hungary in 1998 to that in 2000?
Provide a succinct answer. 0.85. What is the ratio of the PPP conversion factor (LCU per international $) of Costa Rica in 1998 to that in 2001?
Your response must be concise. 0.8. What is the ratio of the PPP conversion factor (LCU per international $) of Czech Republic in 1998 to that in 2001?
Offer a very short reply. 1. What is the ratio of the PPP conversion factor (LCU per international $) of Hungary in 1998 to that in 2001?
Offer a terse response. 0.81. What is the ratio of the PPP conversion factor (LCU per international $) in Costa Rica in 1998 to that in 2002?
Your response must be concise. 0.74. What is the ratio of the PPP conversion factor (LCU per international $) of Czech Republic in 1998 to that in 2002?
Make the answer very short. 0.97. What is the ratio of the PPP conversion factor (LCU per international $) of Hungary in 1998 to that in 2002?
Provide a short and direct response. 0.79. What is the ratio of the PPP conversion factor (LCU per international $) in Costa Rica in 1998 to that in 2003?
Ensure brevity in your answer.  0.7. What is the ratio of the PPP conversion factor (LCU per international $) of Czech Republic in 1998 to that in 2003?
Offer a terse response. 1. What is the ratio of the PPP conversion factor (LCU per international $) of Hungary in 1998 to that in 2003?
Your answer should be very brief. 0.76. What is the ratio of the PPP conversion factor (LCU per international $) in Costa Rica in 1998 to that in 2004?
Keep it short and to the point. 0.64. What is the ratio of the PPP conversion factor (LCU per international $) of Czech Republic in 1998 to that in 2004?
Keep it short and to the point. 0.99. What is the ratio of the PPP conversion factor (LCU per international $) in Hungary in 1998 to that in 2004?
Provide a succinct answer. 0.72. What is the ratio of the PPP conversion factor (LCU per international $) in Costa Rica in 1999 to that in 2000?
Make the answer very short. 0.93. What is the ratio of the PPP conversion factor (LCU per international $) of Hungary in 1999 to that in 2000?
Provide a succinct answer. 0.92. What is the ratio of the PPP conversion factor (LCU per international $) in Costa Rica in 1999 to that in 2001?
Make the answer very short. 0.86. What is the ratio of the PPP conversion factor (LCU per international $) in Czech Republic in 1999 to that in 2001?
Provide a short and direct response. 1.01. What is the ratio of the PPP conversion factor (LCU per international $) of Hungary in 1999 to that in 2001?
Offer a very short reply. 0.88. What is the ratio of the PPP conversion factor (LCU per international $) of Costa Rica in 1999 to that in 2002?
Offer a terse response. 0.8. What is the ratio of the PPP conversion factor (LCU per international $) in Czech Republic in 1999 to that in 2002?
Offer a very short reply. 0.98. What is the ratio of the PPP conversion factor (LCU per international $) of Hungary in 1999 to that in 2002?
Offer a terse response. 0.86. What is the ratio of the PPP conversion factor (LCU per international $) of Costa Rica in 1999 to that in 2003?
Provide a short and direct response. 0.75. What is the ratio of the PPP conversion factor (LCU per international $) in Czech Republic in 1999 to that in 2003?
Offer a terse response. 1.01. What is the ratio of the PPP conversion factor (LCU per international $) in Hungary in 1999 to that in 2003?
Keep it short and to the point. 0.82. What is the ratio of the PPP conversion factor (LCU per international $) in Costa Rica in 1999 to that in 2004?
Offer a very short reply. 0.68. What is the ratio of the PPP conversion factor (LCU per international $) in Czech Republic in 1999 to that in 2004?
Your answer should be very brief. 0.99. What is the ratio of the PPP conversion factor (LCU per international $) in Hungary in 1999 to that in 2004?
Ensure brevity in your answer.  0.78. What is the ratio of the PPP conversion factor (LCU per international $) of Costa Rica in 2000 to that in 2001?
Provide a succinct answer. 0.92. What is the ratio of the PPP conversion factor (LCU per international $) of Czech Republic in 2000 to that in 2001?
Offer a terse response. 1.01. What is the ratio of the PPP conversion factor (LCU per international $) of Hungary in 2000 to that in 2001?
Make the answer very short. 0.95. What is the ratio of the PPP conversion factor (LCU per international $) of Costa Rica in 2000 to that in 2002?
Your answer should be compact. 0.86. What is the ratio of the PPP conversion factor (LCU per international $) in Czech Republic in 2000 to that in 2002?
Your answer should be compact. 0.99. What is the ratio of the PPP conversion factor (LCU per international $) in Hungary in 2000 to that in 2002?
Ensure brevity in your answer.  0.93. What is the ratio of the PPP conversion factor (LCU per international $) of Costa Rica in 2000 to that in 2003?
Your answer should be very brief. 0.8. What is the ratio of the PPP conversion factor (LCU per international $) in Czech Republic in 2000 to that in 2003?
Make the answer very short. 1.01. What is the ratio of the PPP conversion factor (LCU per international $) in Hungary in 2000 to that in 2003?
Your answer should be very brief. 0.89. What is the ratio of the PPP conversion factor (LCU per international $) in Costa Rica in 2000 to that in 2004?
Make the answer very short. 0.73. What is the ratio of the PPP conversion factor (LCU per international $) of Hungary in 2000 to that in 2004?
Give a very brief answer. 0.85. What is the ratio of the PPP conversion factor (LCU per international $) in Costa Rica in 2001 to that in 2002?
Your answer should be very brief. 0.93. What is the ratio of the PPP conversion factor (LCU per international $) of Czech Republic in 2001 to that in 2002?
Your answer should be compact. 0.97. What is the ratio of the PPP conversion factor (LCU per international $) in Hungary in 2001 to that in 2002?
Your answer should be very brief. 0.98. What is the ratio of the PPP conversion factor (LCU per international $) in Costa Rica in 2001 to that in 2003?
Offer a terse response. 0.87. What is the ratio of the PPP conversion factor (LCU per international $) in Hungary in 2001 to that in 2003?
Keep it short and to the point. 0.94. What is the ratio of the PPP conversion factor (LCU per international $) of Costa Rica in 2001 to that in 2004?
Provide a short and direct response. 0.79. What is the ratio of the PPP conversion factor (LCU per international $) of Hungary in 2001 to that in 2004?
Offer a very short reply. 0.89. What is the ratio of the PPP conversion factor (LCU per international $) of Costa Rica in 2002 to that in 2003?
Provide a succinct answer. 0.93. What is the ratio of the PPP conversion factor (LCU per international $) in Czech Republic in 2002 to that in 2003?
Provide a short and direct response. 1.03. What is the ratio of the PPP conversion factor (LCU per international $) of Hungary in 2002 to that in 2003?
Give a very brief answer. 0.96. What is the ratio of the PPP conversion factor (LCU per international $) in Costa Rica in 2002 to that in 2004?
Make the answer very short. 0.85. What is the ratio of the PPP conversion factor (LCU per international $) in Czech Republic in 2002 to that in 2004?
Provide a succinct answer. 1.01. What is the ratio of the PPP conversion factor (LCU per international $) of Hungary in 2002 to that in 2004?
Your response must be concise. 0.91. What is the ratio of the PPP conversion factor (LCU per international $) of Costa Rica in 2003 to that in 2004?
Offer a very short reply. 0.91. What is the ratio of the PPP conversion factor (LCU per international $) of Czech Republic in 2003 to that in 2004?
Your answer should be very brief. 0.99. What is the ratio of the PPP conversion factor (LCU per international $) of Hungary in 2003 to that in 2004?
Your answer should be very brief. 0.95. What is the difference between the highest and the second highest PPP conversion factor (LCU per international $) of Costa Rica?
Your response must be concise. 18.68. What is the difference between the highest and the second highest PPP conversion factor (LCU per international $) of Czech Republic?
Your response must be concise. 0.22. What is the difference between the highest and the second highest PPP conversion factor (LCU per international $) of Hungary?
Your response must be concise. 6.65. What is the difference between the highest and the lowest PPP conversion factor (LCU per international $) in Costa Rica?
Your response must be concise. 91.87. What is the difference between the highest and the lowest PPP conversion factor (LCU per international $) of Czech Republic?
Provide a succinct answer. 1.51. What is the difference between the highest and the lowest PPP conversion factor (LCU per international $) of Hungary?
Provide a succinct answer. 48.85. 